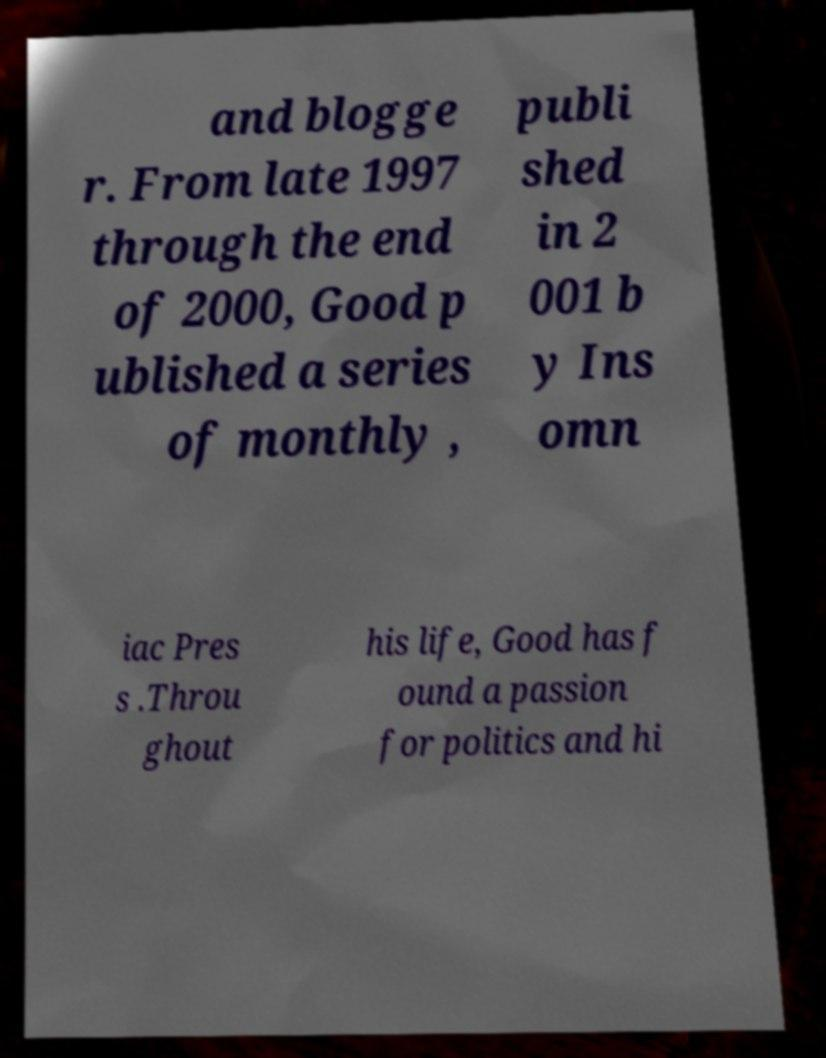I need the written content from this picture converted into text. Can you do that? and blogge r. From late 1997 through the end of 2000, Good p ublished a series of monthly , publi shed in 2 001 b y Ins omn iac Pres s .Throu ghout his life, Good has f ound a passion for politics and hi 